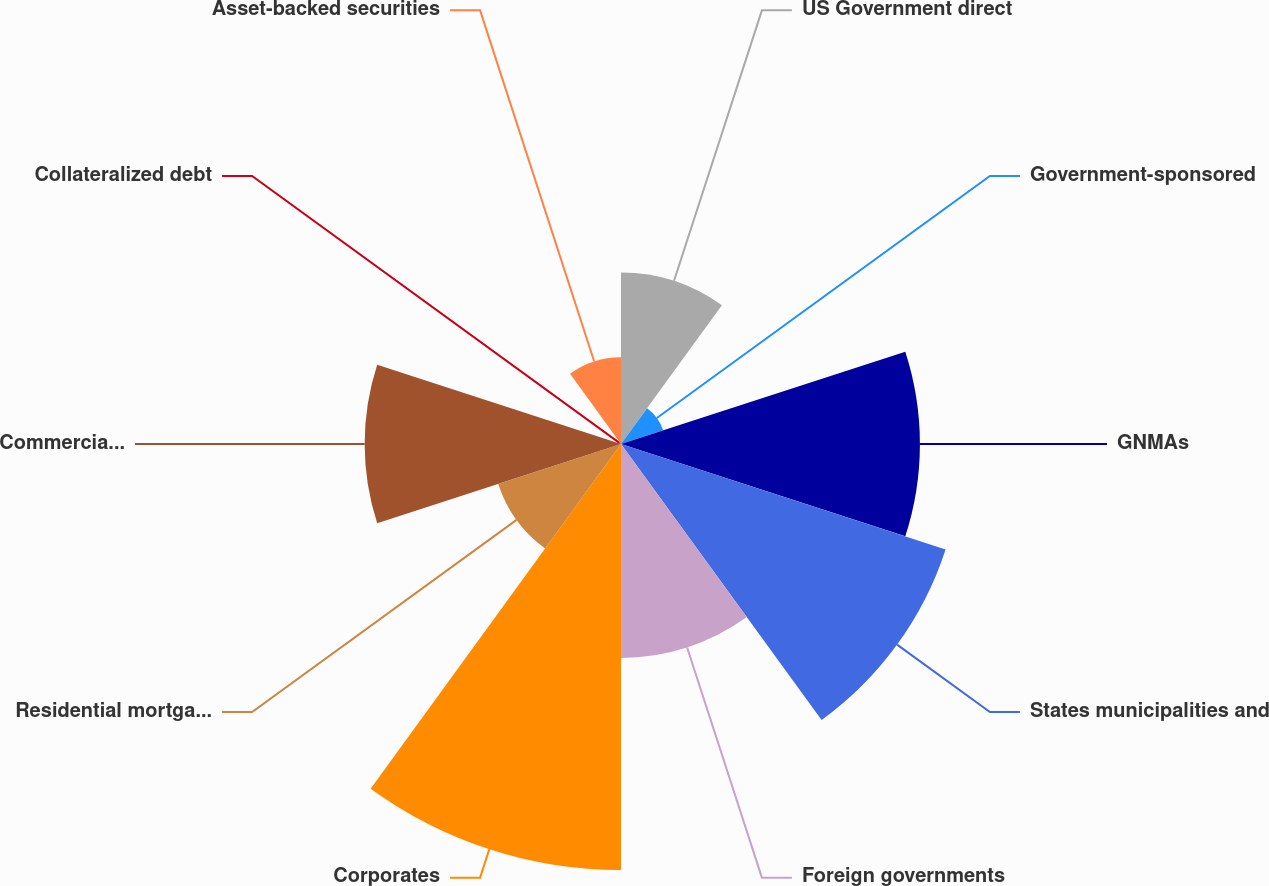<chart> <loc_0><loc_0><loc_500><loc_500><pie_chart><fcel>US Government direct<fcel>Government-sponsored<fcel>GNMAs<fcel>States municipalities and<fcel>Foreign governments<fcel>Corporates<fcel>Residential mortgage-backed<fcel>Commercial mortgage-backed<fcel>Collateralized debt<fcel>Asset-backed securities<nl><fcel>8.71%<fcel>2.25%<fcel>15.17%<fcel>17.32%<fcel>10.86%<fcel>21.62%<fcel>6.55%<fcel>13.01%<fcel>0.1%<fcel>4.4%<nl></chart> 